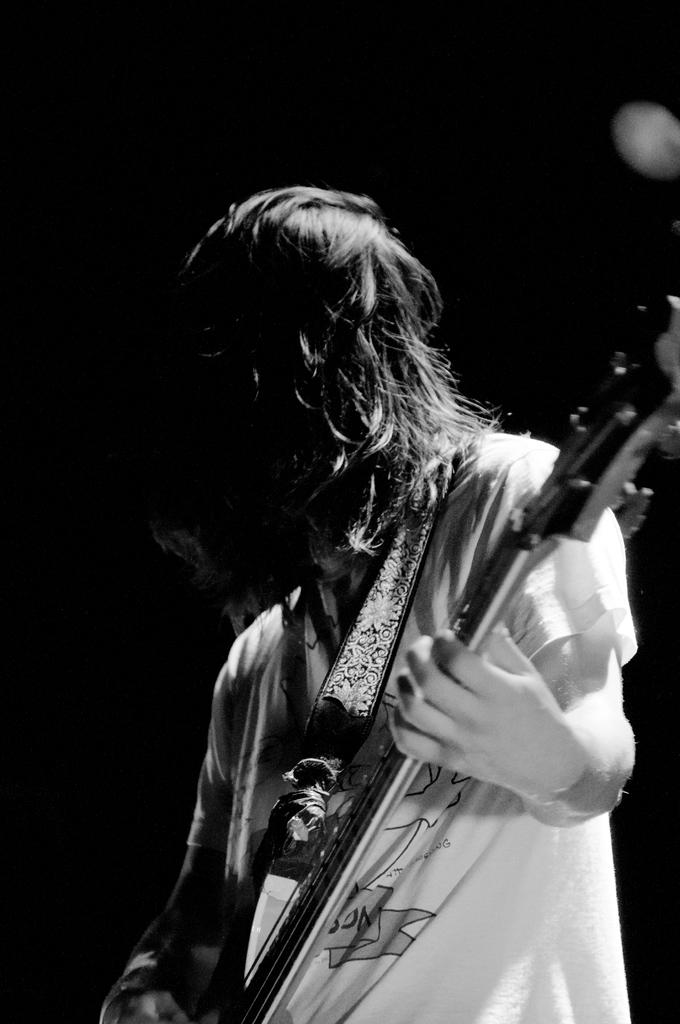What is the main subject of the image? There is a person in the image. What is the person doing in the image? The person is standing and playing a guitar. What time does the clock show in the image? There is no clock present in the image. How does the person shake the guitar in the image? The person is not shaking the guitar in the image; they are playing it. 